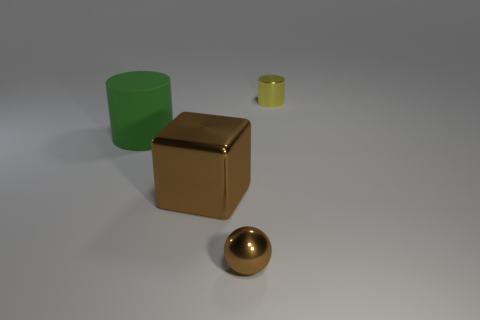Is there any other thing that is made of the same material as the green cylinder?
Provide a succinct answer. No. There is a matte object; is it the same shape as the small object that is right of the small brown shiny sphere?
Provide a succinct answer. Yes. What number of other objects are there of the same shape as the large green object?
Your answer should be very brief. 1. How many objects are either tiny brown shiny balls or tiny purple cylinders?
Ensure brevity in your answer.  1. Does the sphere have the same color as the large block?
Provide a short and direct response. Yes. What is the shape of the green thing that is left of the small shiny thing in front of the big green matte cylinder?
Ensure brevity in your answer.  Cylinder. Are there fewer objects than small gray shiny spheres?
Offer a very short reply. No. There is a thing that is both behind the large metallic thing and to the right of the brown cube; what is its size?
Provide a short and direct response. Small. Is the size of the green matte thing the same as the yellow cylinder?
Provide a succinct answer. No. Does the metallic object left of the metallic ball have the same color as the metal sphere?
Provide a short and direct response. Yes. 